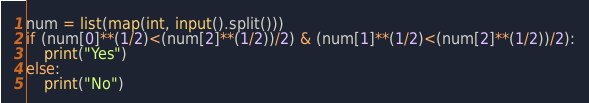<code> <loc_0><loc_0><loc_500><loc_500><_Python_>num = list(map(int, input().split()))
if (num[0]**(1/2)<(num[2]**(1/2))/2) & (num[1]**(1/2)<(num[2]**(1/2))/2):
    print("Yes")
else:
    print("No")</code> 